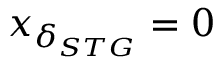Convert formula to latex. <formula><loc_0><loc_0><loc_500><loc_500>x _ { \delta _ { S T G } } = 0</formula> 